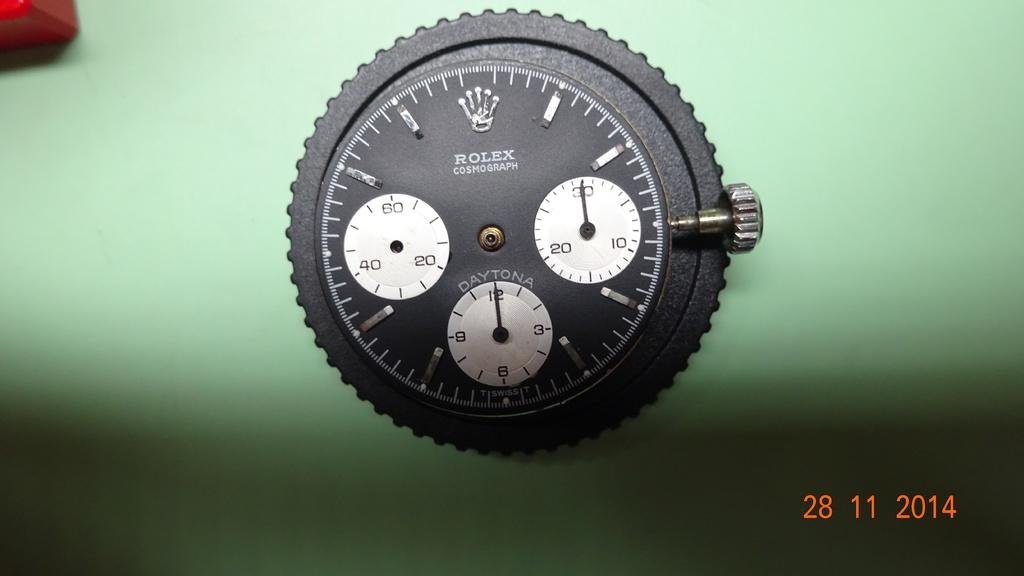Provide a one-sentence caption for the provided image. A black Rolex stop watch is seen close up against a green background. 